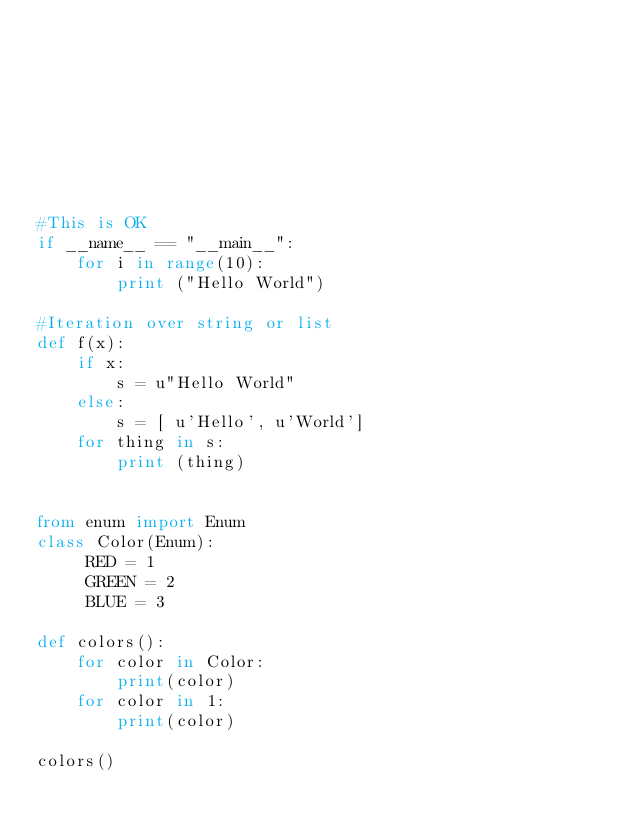<code> <loc_0><loc_0><loc_500><loc_500><_Python_>








#This is OK
if __name__ == "__main__":
    for i in range(10):
        print ("Hello World")

#Iteration over string or list
def f(x):
    if x:
        s = u"Hello World"
    else:
        s = [ u'Hello', u'World']
    for thing in s:
        print (thing)


from enum import Enum
class Color(Enum):
     RED = 1
     GREEN = 2
     BLUE = 3

def colors():
    for color in Color:
        print(color)
    for color in 1:
        print(color)

colors()

</code> 